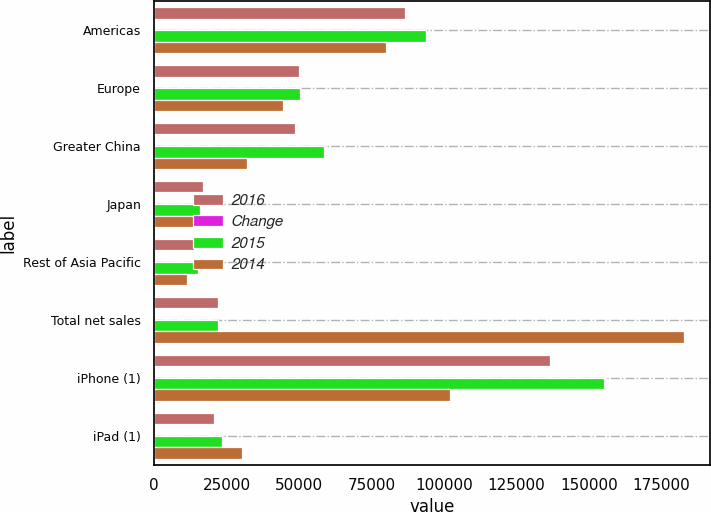<chart> <loc_0><loc_0><loc_500><loc_500><stacked_bar_chart><ecel><fcel>Americas<fcel>Europe<fcel>Greater China<fcel>Japan<fcel>Rest of Asia Pacific<fcel>Total net sales<fcel>iPhone (1)<fcel>iPad (1)<nl><fcel>2016<fcel>86613<fcel>49952<fcel>48492<fcel>16928<fcel>13654<fcel>21927.5<fcel>136700<fcel>20628<nl><fcel>Change<fcel>8<fcel>1<fcel>17<fcel>8<fcel>10<fcel>8<fcel>12<fcel>11<nl><fcel>2015<fcel>93864<fcel>50337<fcel>58715<fcel>15706<fcel>15093<fcel>21927.5<fcel>155041<fcel>23227<nl><fcel>2014<fcel>80095<fcel>44285<fcel>31853<fcel>15314<fcel>11248<fcel>182795<fcel>101991<fcel>30283<nl></chart> 